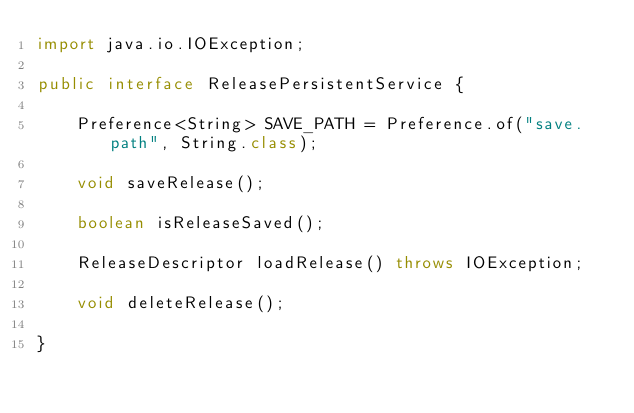<code> <loc_0><loc_0><loc_500><loc_500><_Java_>import java.io.IOException;

public interface ReleasePersistentService {

    Preference<String> SAVE_PATH = Preference.of("save.path", String.class);

    void saveRelease();

    boolean isReleaseSaved();

    ReleaseDescriptor loadRelease() throws IOException;

    void deleteRelease();

}
</code> 